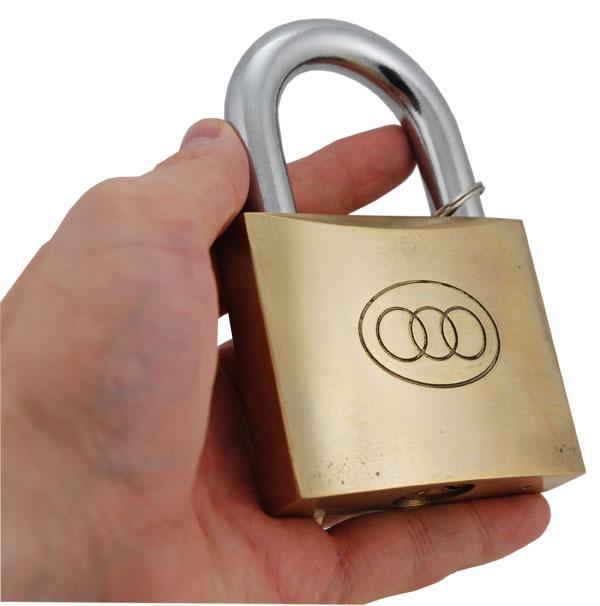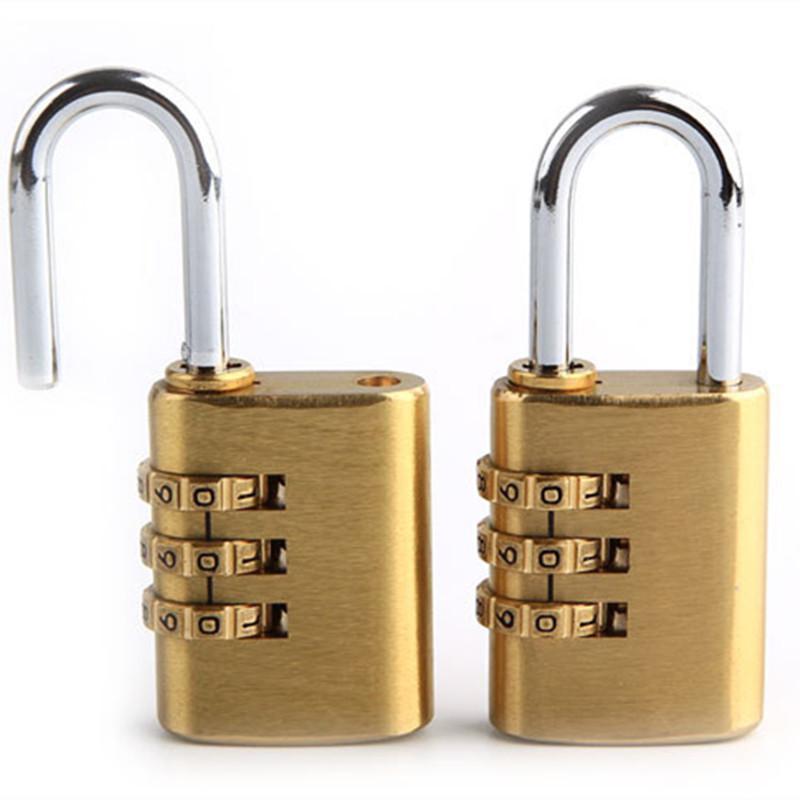The first image is the image on the left, the second image is the image on the right. Examine the images to the left and right. Is the description "In one image of each pair there is a keyhole on the front of the lock." accurate? Answer yes or no. No. The first image is the image on the left, the second image is the image on the right. Examine the images to the left and right. Is the description "There are at least 3 keys present, next to locks." accurate? Answer yes or no. No. 